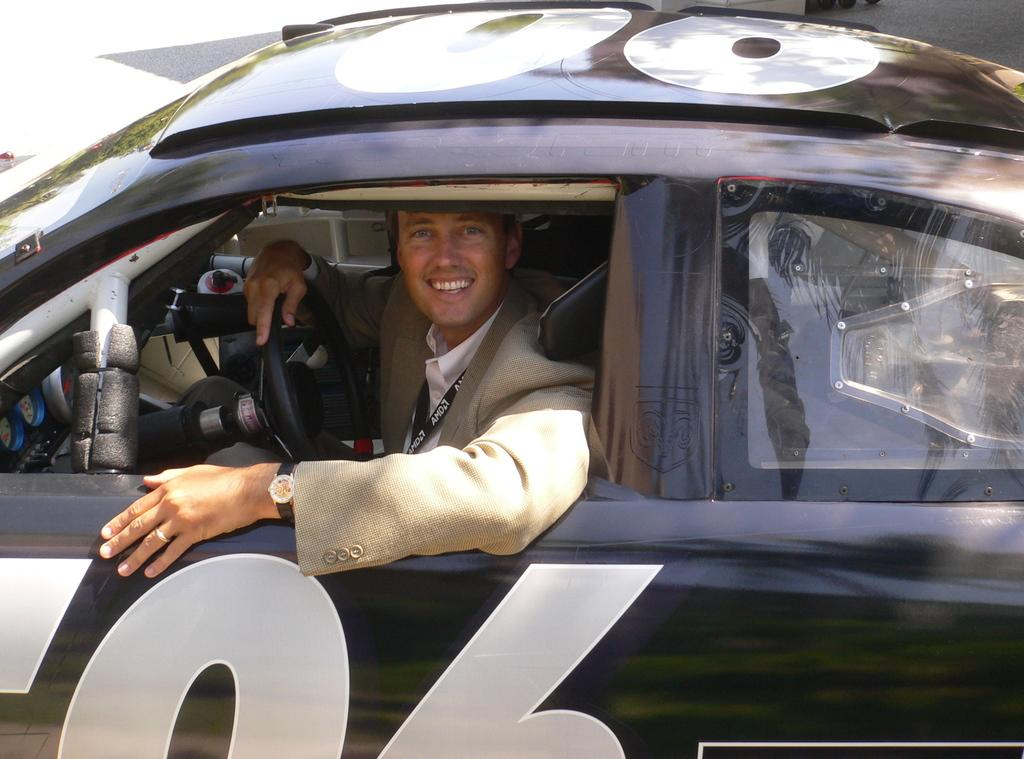What is the setting of the image? The image is on a road. What type of vehicle is in the image? There is a black car in the image. Who is inside the black car? A person is sitting inside the black car. What is the person's expression in the image? The person is smiling. What is the person doing while sitting in the car? The person is holding the steering wheel. What type of unit can be seen in the image? There is no unit present in the image; it features a black car on a road with a person inside. Is there a basin visible in the image? No, there is no basin present in the image. 